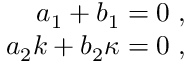Convert formula to latex. <formula><loc_0><loc_0><loc_500><loc_500>\begin{array} { r } { a _ { 1 } + b _ { 1 } = 0 \, , } \\ { a _ { 2 } k + b _ { 2 } \kappa = 0 \, , } \end{array}</formula> 